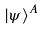<formula> <loc_0><loc_0><loc_500><loc_500>| \psi \rangle ^ { A }</formula> 